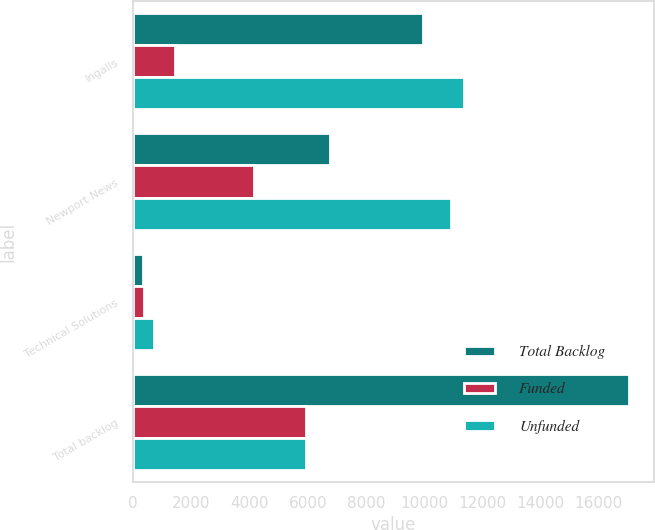<chart> <loc_0><loc_0><loc_500><loc_500><stacked_bar_chart><ecel><fcel>Ingalls<fcel>Newport News<fcel>Technical Solutions<fcel>Total backlog<nl><fcel>Total Backlog<fcel>9943<fcel>6767<fcel>339<fcel>17049<nl><fcel>Funded<fcel>1422<fcel>4144<fcel>380<fcel>5946<nl><fcel>Unfunded<fcel>11365<fcel>10911<fcel>719<fcel>5946<nl></chart> 